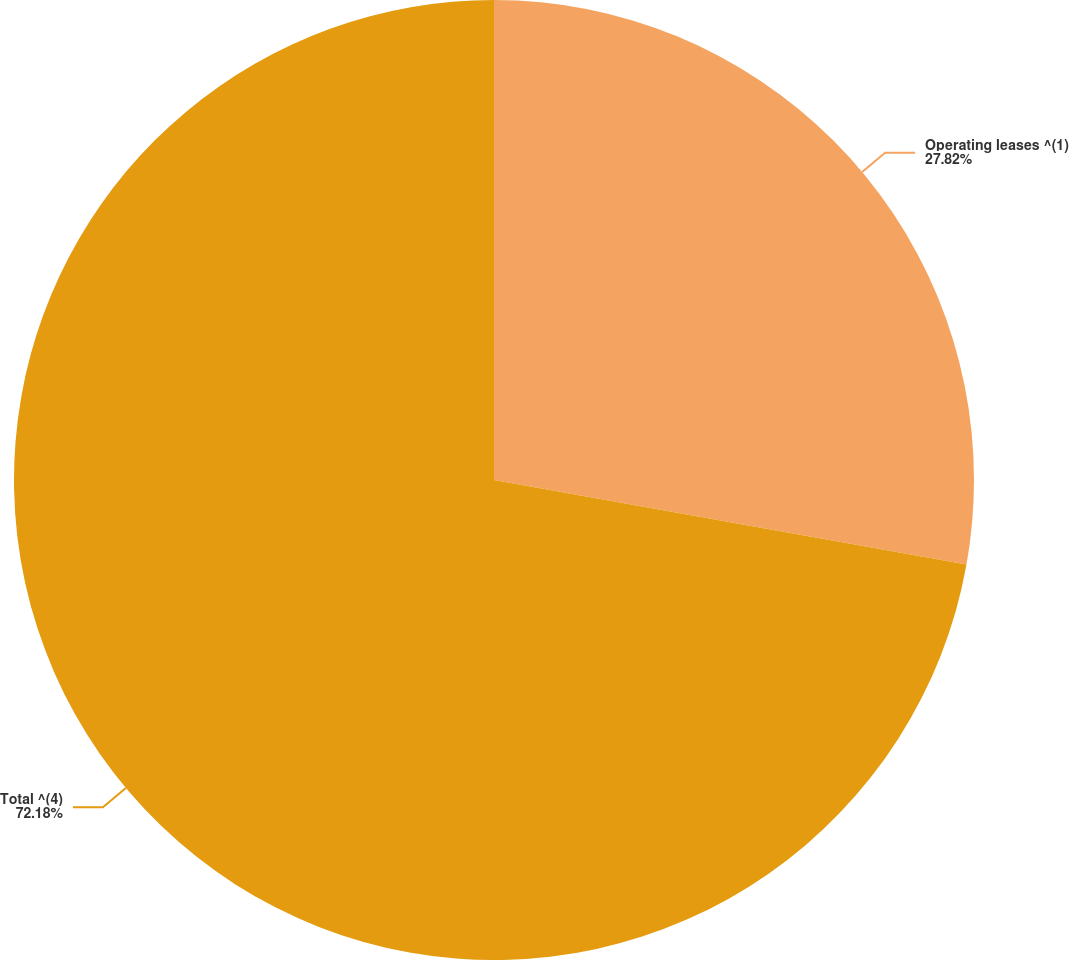Convert chart to OTSL. <chart><loc_0><loc_0><loc_500><loc_500><pie_chart><fcel>Operating leases ^(1)<fcel>Total ^(4)<nl><fcel>27.82%<fcel>72.18%<nl></chart> 